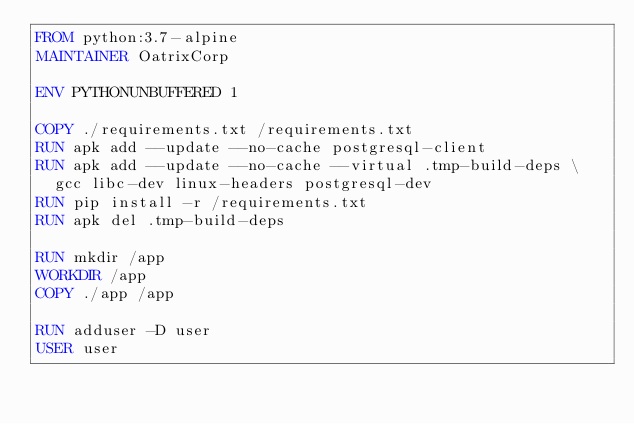Convert code to text. <code><loc_0><loc_0><loc_500><loc_500><_Dockerfile_>FROM python:3.7-alpine
MAINTAINER OatrixCorp

ENV PYTHONUNBUFFERED 1

COPY ./requirements.txt /requirements.txt
RUN apk add --update --no-cache postgresql-client
RUN apk add --update --no-cache --virtual .tmp-build-deps \
  gcc libc-dev linux-headers postgresql-dev
RUN pip install -r /requirements.txt
RUN apk del .tmp-build-deps

RUN mkdir /app
WORKDIR /app
COPY ./app /app

RUN adduser -D user
USER user
</code> 